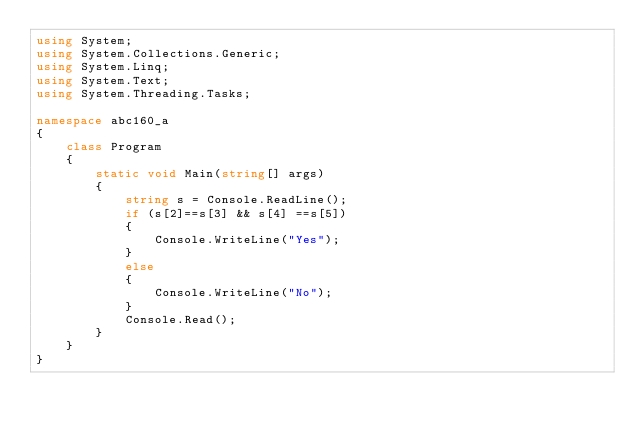<code> <loc_0><loc_0><loc_500><loc_500><_C#_>using System;
using System.Collections.Generic;
using System.Linq;
using System.Text;
using System.Threading.Tasks;

namespace abc160_a
{
    class Program
    {
        static void Main(string[] args)
        {
            string s = Console.ReadLine();
            if (s[2]==s[3] && s[4] ==s[5])
            {
                Console.WriteLine("Yes");
            }
            else
            {
                Console.WriteLine("No");
            }
            Console.Read();
        }
    }
}
</code> 